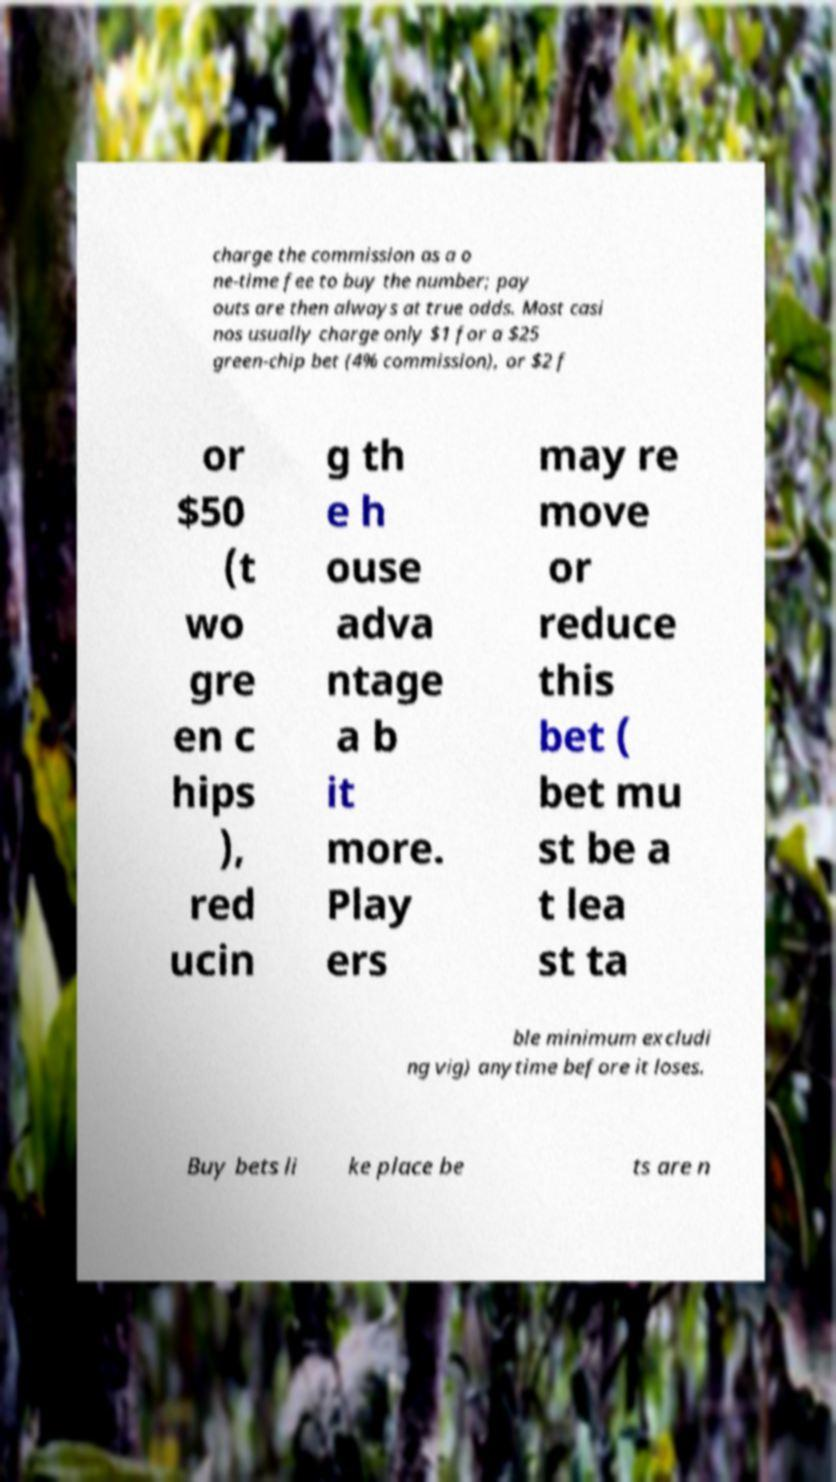Please identify and transcribe the text found in this image. charge the commission as a o ne-time fee to buy the number; pay outs are then always at true odds. Most casi nos usually charge only $1 for a $25 green-chip bet (4% commission), or $2 f or $50 (t wo gre en c hips ), red ucin g th e h ouse adva ntage a b it more. Play ers may re move or reduce this bet ( bet mu st be a t lea st ta ble minimum excludi ng vig) anytime before it loses. Buy bets li ke place be ts are n 